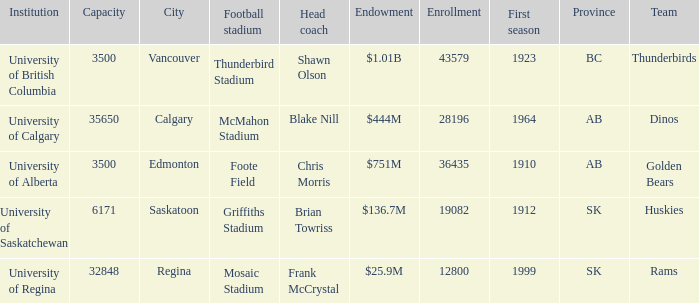How many cities have an enrollment of 19082? 1.0. 